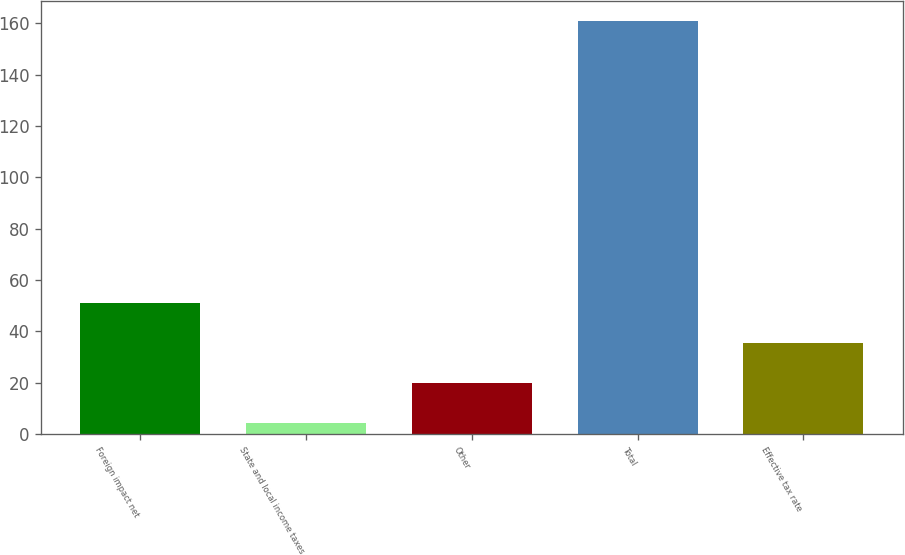<chart> <loc_0><loc_0><loc_500><loc_500><bar_chart><fcel>Foreign impact net<fcel>State and local income taxes<fcel>Other<fcel>Total<fcel>Effective tax rate<nl><fcel>51.18<fcel>4.2<fcel>19.86<fcel>160.8<fcel>35.52<nl></chart> 